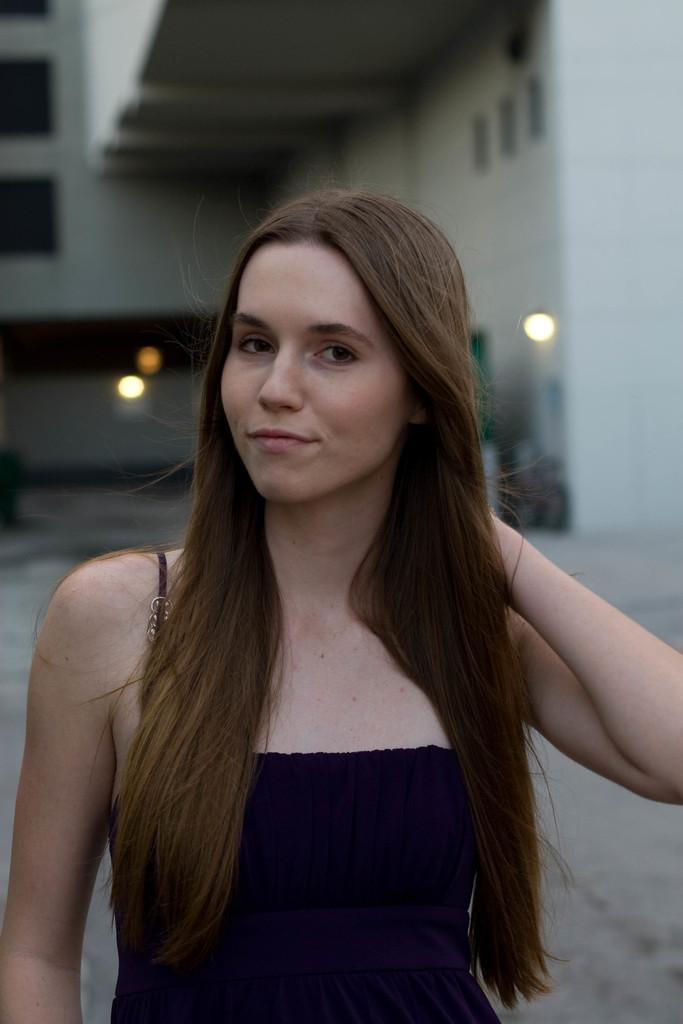Can you describe this image briefly? In this image I can see a woman is standing and smiling. In the background I can see a building, lights and other objects. The background of the image is blurred. 